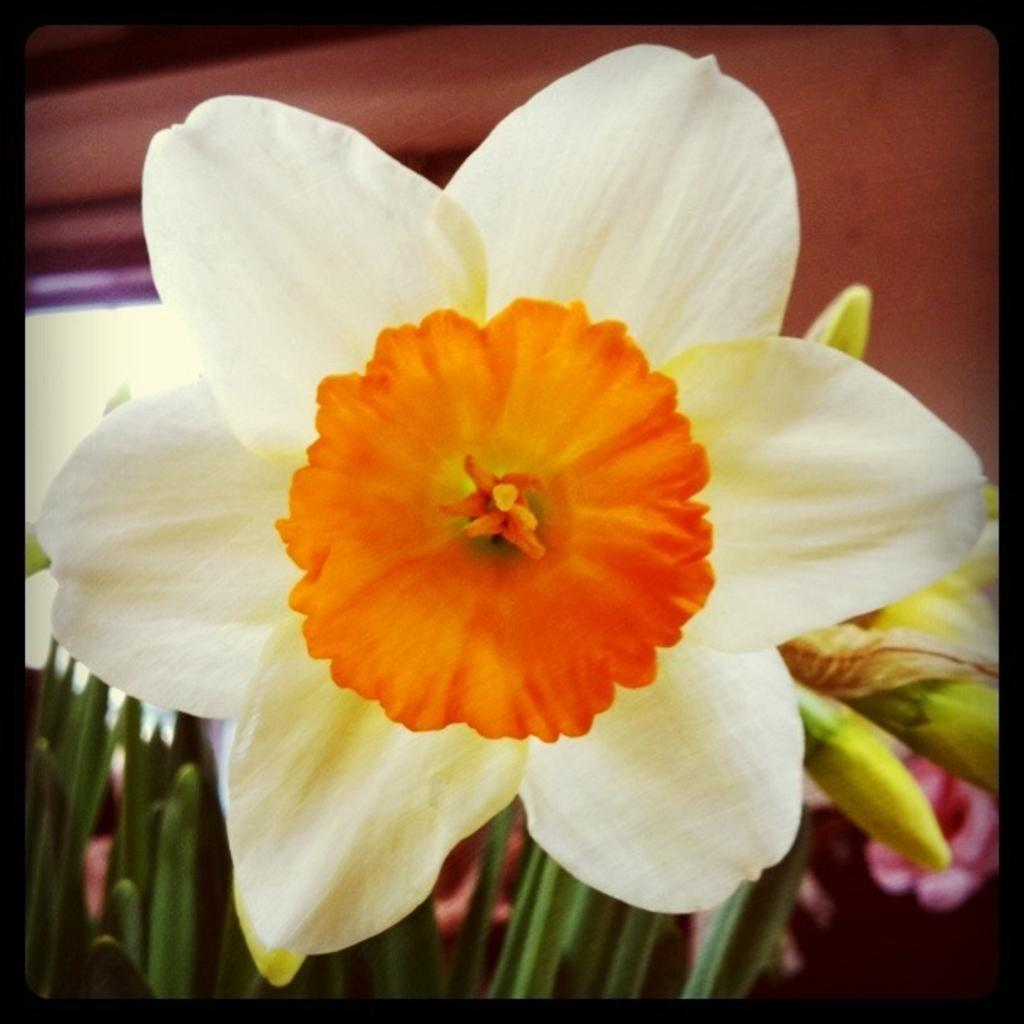What type of living organism is present in the image? There is a plant in the image. What are the reproductive structures of the plant? The plant has flowers and buds. What type of coal can be seen in the image? There is no coal present in the image; it features a plant with flowers and buds. How does the plant tie a knot in the image? Plants do not have the ability to tie knots, so this action cannot be observed in the image. 